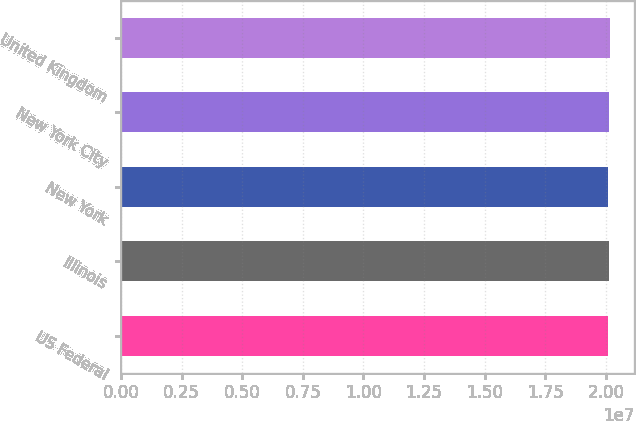Convert chart. <chart><loc_0><loc_0><loc_500><loc_500><bar_chart><fcel>US Federal<fcel>Illinois<fcel>New York<fcel>New York City<fcel>United Kingdom<nl><fcel>2.0082e+07<fcel>2.0152e+07<fcel>2.0112e+07<fcel>2.012e+07<fcel>2.0162e+07<nl></chart> 